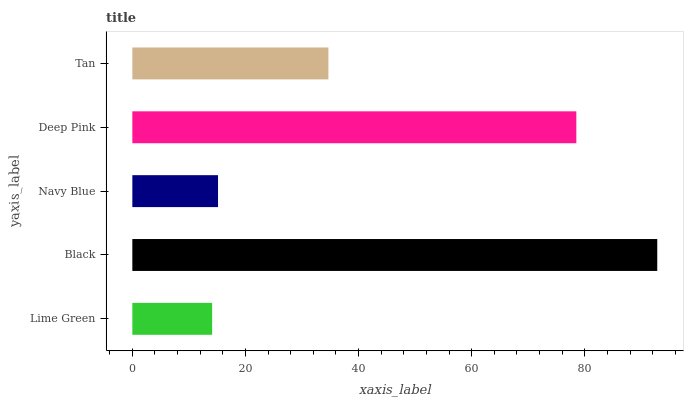Is Lime Green the minimum?
Answer yes or no. Yes. Is Black the maximum?
Answer yes or no. Yes. Is Navy Blue the minimum?
Answer yes or no. No. Is Navy Blue the maximum?
Answer yes or no. No. Is Black greater than Navy Blue?
Answer yes or no. Yes. Is Navy Blue less than Black?
Answer yes or no. Yes. Is Navy Blue greater than Black?
Answer yes or no. No. Is Black less than Navy Blue?
Answer yes or no. No. Is Tan the high median?
Answer yes or no. Yes. Is Tan the low median?
Answer yes or no. Yes. Is Lime Green the high median?
Answer yes or no. No. Is Black the low median?
Answer yes or no. No. 